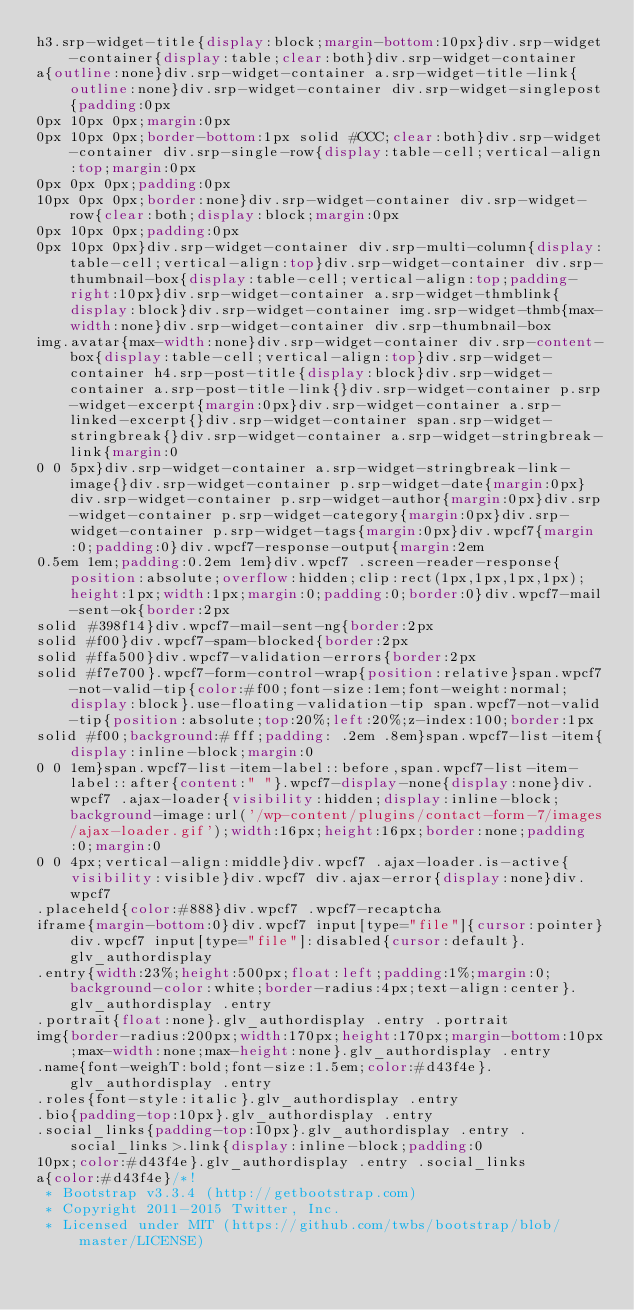Convert code to text. <code><loc_0><loc_0><loc_500><loc_500><_CSS_>h3.srp-widget-title{display:block;margin-bottom:10px}div.srp-widget-container{display:table;clear:both}div.srp-widget-container
a{outline:none}div.srp-widget-container a.srp-widget-title-link{outline:none}div.srp-widget-container div.srp-widget-singlepost{padding:0px
0px 10px 0px;margin:0px
0px 10px 0px;border-bottom:1px solid #CCC;clear:both}div.srp-widget-container div.srp-single-row{display:table-cell;vertical-align:top;margin:0px
0px 0px 0px;padding:0px
10px 0px 0px;border:none}div.srp-widget-container div.srp-widget-row{clear:both;display:block;margin:0px
0px 10px 0px;padding:0px
0px 10px 0px}div.srp-widget-container div.srp-multi-column{display:table-cell;vertical-align:top}div.srp-widget-container div.srp-thumbnail-box{display:table-cell;vertical-align:top;padding-right:10px}div.srp-widget-container a.srp-widget-thmblink{display:block}div.srp-widget-container img.srp-widget-thmb{max-width:none}div.srp-widget-container div.srp-thumbnail-box
img.avatar{max-width:none}div.srp-widget-container div.srp-content-box{display:table-cell;vertical-align:top}div.srp-widget-container h4.srp-post-title{display:block}div.srp-widget-container a.srp-post-title-link{}div.srp-widget-container p.srp-widget-excerpt{margin:0px}div.srp-widget-container a.srp-linked-excerpt{}div.srp-widget-container span.srp-widget-stringbreak{}div.srp-widget-container a.srp-widget-stringbreak-link{margin:0
0 0 5px}div.srp-widget-container a.srp-widget-stringbreak-link-image{}div.srp-widget-container p.srp-widget-date{margin:0px}div.srp-widget-container p.srp-widget-author{margin:0px}div.srp-widget-container p.srp-widget-category{margin:0px}div.srp-widget-container p.srp-widget-tags{margin:0px}div.wpcf7{margin:0;padding:0}div.wpcf7-response-output{margin:2em
0.5em 1em;padding:0.2em 1em}div.wpcf7 .screen-reader-response{position:absolute;overflow:hidden;clip:rect(1px,1px,1px,1px);height:1px;width:1px;margin:0;padding:0;border:0}div.wpcf7-mail-sent-ok{border:2px
solid #398f14}div.wpcf7-mail-sent-ng{border:2px
solid #f00}div.wpcf7-spam-blocked{border:2px
solid #ffa500}div.wpcf7-validation-errors{border:2px
solid #f7e700}.wpcf7-form-control-wrap{position:relative}span.wpcf7-not-valid-tip{color:#f00;font-size:1em;font-weight:normal;display:block}.use-floating-validation-tip span.wpcf7-not-valid-tip{position:absolute;top:20%;left:20%;z-index:100;border:1px
solid #f00;background:#fff;padding: .2em .8em}span.wpcf7-list-item{display:inline-block;margin:0
0 0 1em}span.wpcf7-list-item-label::before,span.wpcf7-list-item-label::after{content:" "}.wpcf7-display-none{display:none}div.wpcf7 .ajax-loader{visibility:hidden;display:inline-block;background-image:url('/wp-content/plugins/contact-form-7/images/ajax-loader.gif');width:16px;height:16px;border:none;padding:0;margin:0
0 0 4px;vertical-align:middle}div.wpcf7 .ajax-loader.is-active{visibility:visible}div.wpcf7 div.ajax-error{display:none}div.wpcf7
.placeheld{color:#888}div.wpcf7 .wpcf7-recaptcha
iframe{margin-bottom:0}div.wpcf7 input[type="file"]{cursor:pointer}div.wpcf7 input[type="file"]:disabled{cursor:default}.glv_authordisplay
.entry{width:23%;height:500px;float:left;padding:1%;margin:0;background-color:white;border-radius:4px;text-align:center}.glv_authordisplay .entry
.portrait{float:none}.glv_authordisplay .entry .portrait
img{border-radius:200px;width:170px;height:170px;margin-bottom:10px;max-width:none;max-height:none}.glv_authordisplay .entry
.name{font-weighT:bold;font-size:1.5em;color:#d43f4e}.glv_authordisplay .entry
.roles{font-style:italic}.glv_authordisplay .entry
.bio{padding-top:10px}.glv_authordisplay .entry
.social_links{padding-top:10px}.glv_authordisplay .entry .social_links>.link{display:inline-block;padding:0
10px;color:#d43f4e}.glv_authordisplay .entry .social_links
a{color:#d43f4e}/*!
 * Bootstrap v3.3.4 (http://getbootstrap.com)
 * Copyright 2011-2015 Twitter, Inc.
 * Licensed under MIT (https://github.com/twbs/bootstrap/blob/master/LICENSE)</code> 